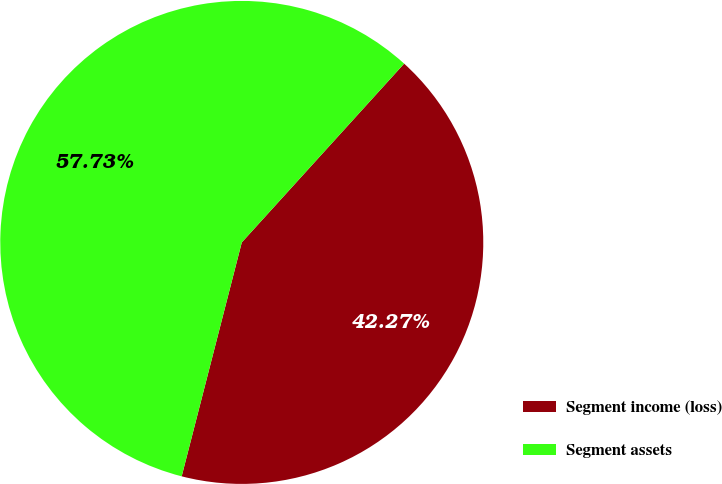<chart> <loc_0><loc_0><loc_500><loc_500><pie_chart><fcel>Segment income (loss)<fcel>Segment assets<nl><fcel>42.27%<fcel>57.73%<nl></chart> 